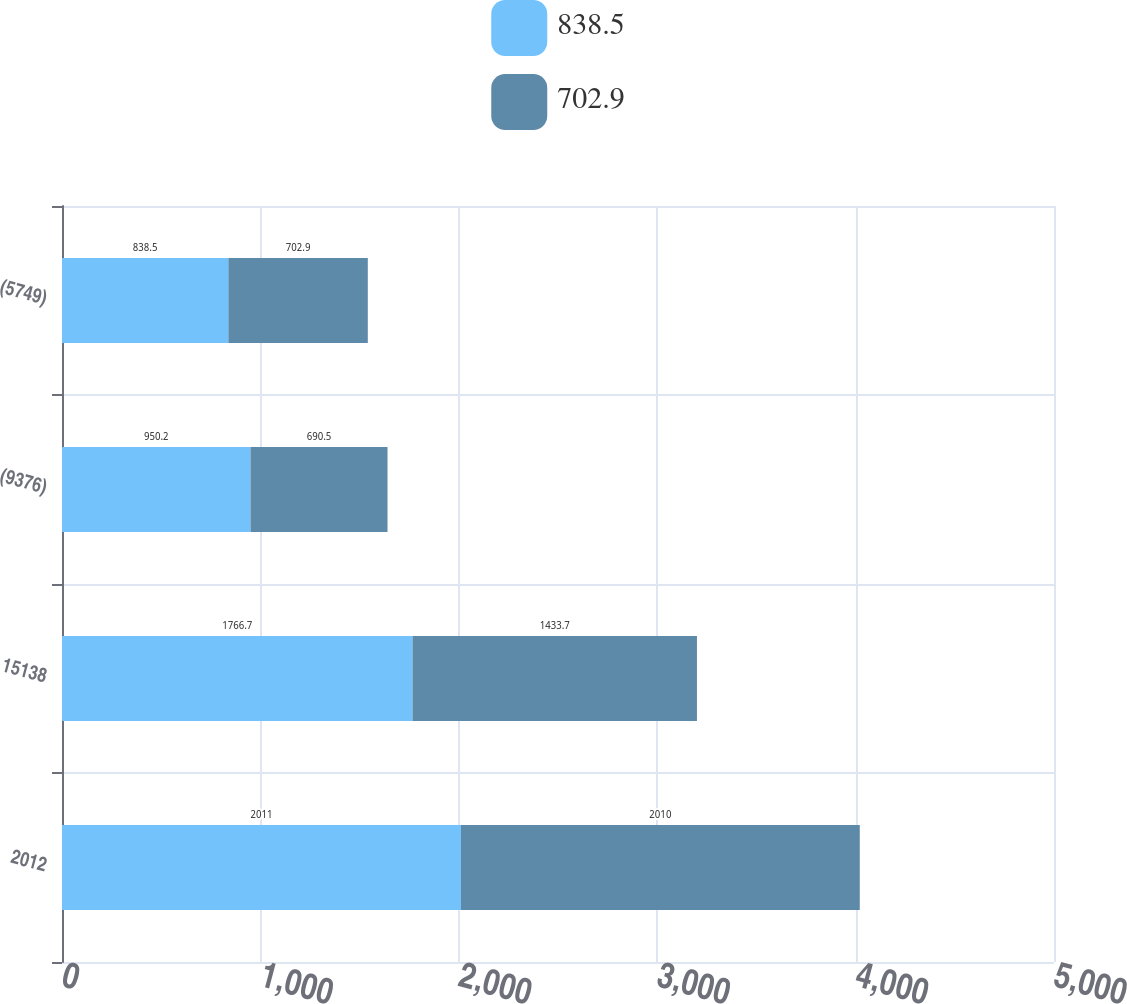<chart> <loc_0><loc_0><loc_500><loc_500><stacked_bar_chart><ecel><fcel>2012<fcel>15138<fcel>(9376)<fcel>(5749)<nl><fcel>838.5<fcel>2011<fcel>1766.7<fcel>950.2<fcel>838.5<nl><fcel>702.9<fcel>2010<fcel>1433.7<fcel>690.5<fcel>702.9<nl></chart> 